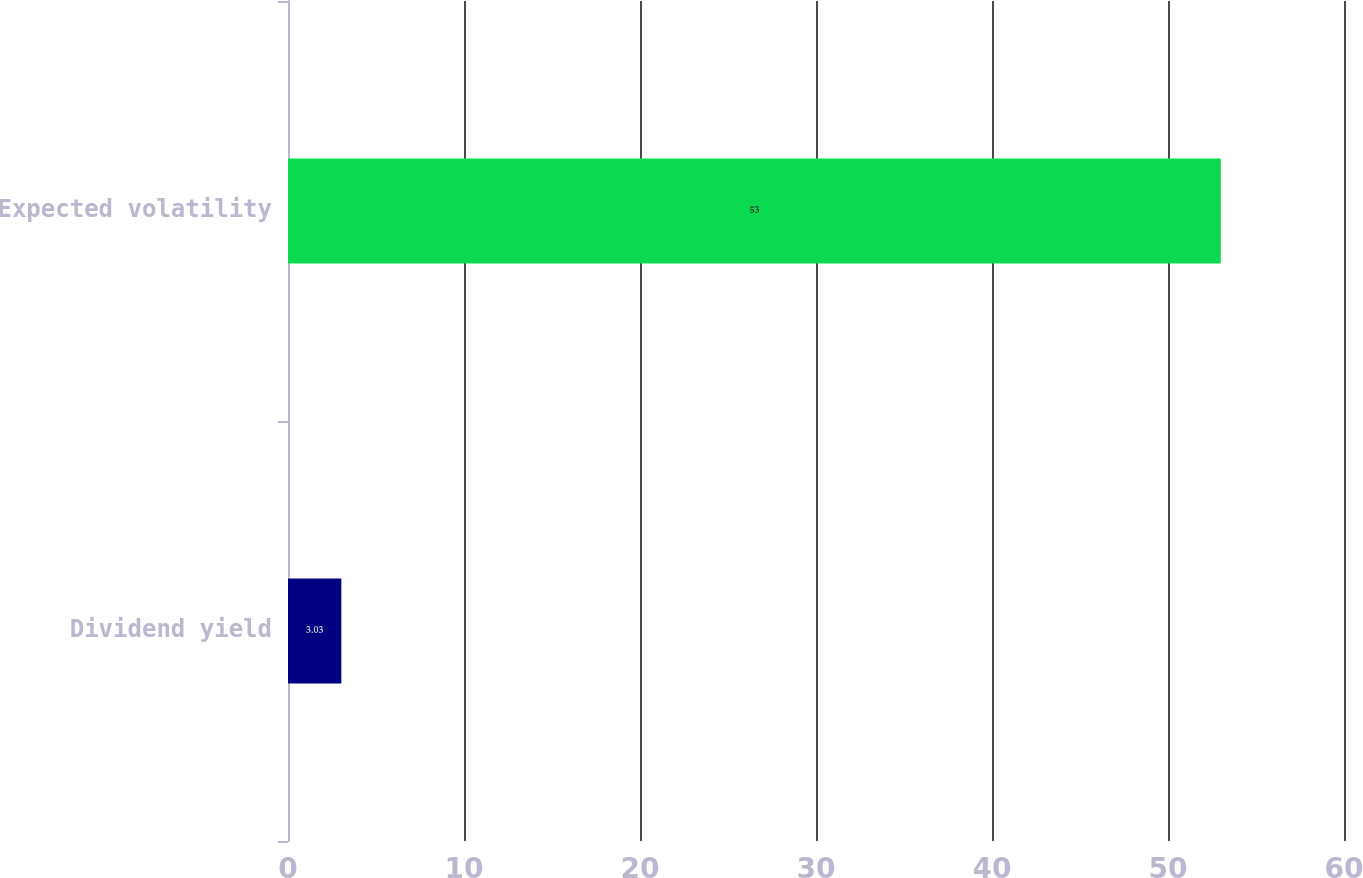<chart> <loc_0><loc_0><loc_500><loc_500><bar_chart><fcel>Dividend yield<fcel>Expected volatility<nl><fcel>3.03<fcel>53<nl></chart> 